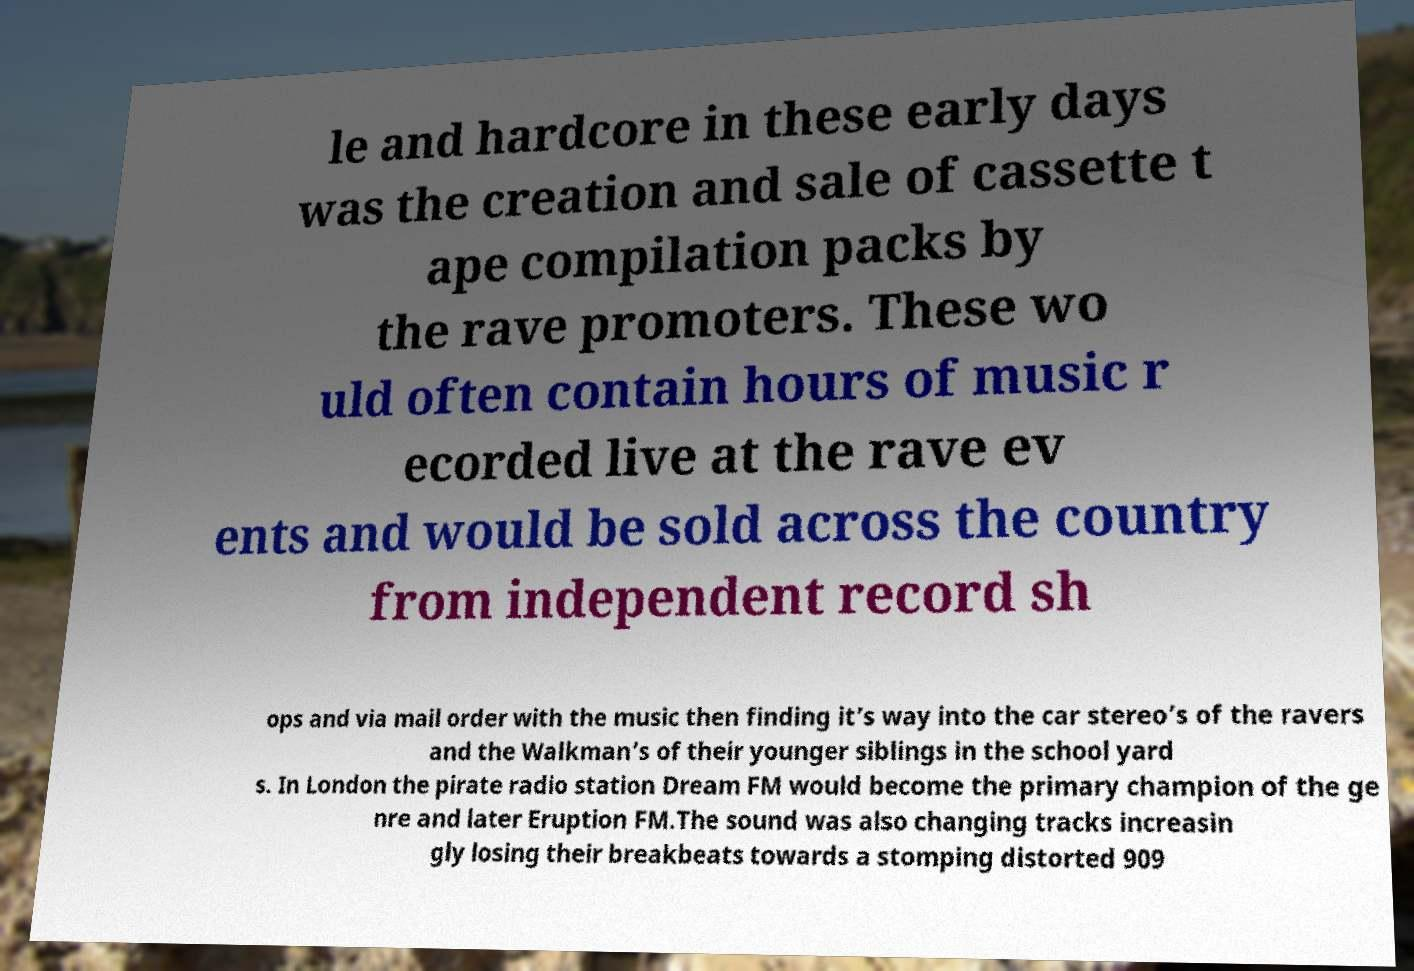Could you extract and type out the text from this image? le and hardcore in these early days was the creation and sale of cassette t ape compilation packs by the rave promoters. These wo uld often contain hours of music r ecorded live at the rave ev ents and would be sold across the country from independent record sh ops and via mail order with the music then finding it’s way into the car stereo’s of the ravers and the Walkman’s of their younger siblings in the school yard s. In London the pirate radio station Dream FM would become the primary champion of the ge nre and later Eruption FM.The sound was also changing tracks increasin gly losing their breakbeats towards a stomping distorted 909 